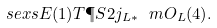Convert formula to latex. <formula><loc_0><loc_0><loc_500><loc_500>\ s e x s { E ( 1 ) } { T \P S { 2 } } { j _ { L * } \ m O _ { L } ( 4 ) } .</formula> 